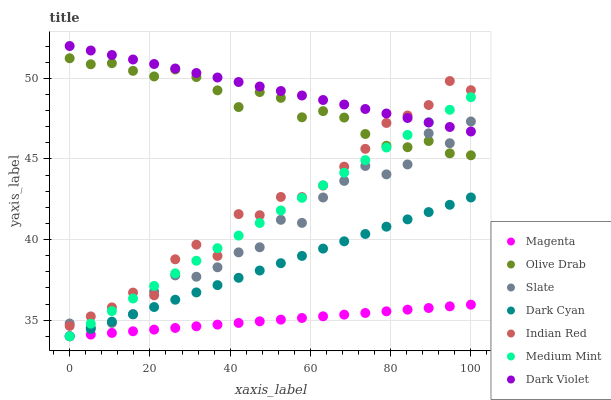Does Magenta have the minimum area under the curve?
Answer yes or no. Yes. Does Dark Violet have the maximum area under the curve?
Answer yes or no. Yes. Does Slate have the minimum area under the curve?
Answer yes or no. No. Does Slate have the maximum area under the curve?
Answer yes or no. No. Is Magenta the smoothest?
Answer yes or no. Yes. Is Indian Red the roughest?
Answer yes or no. Yes. Is Slate the smoothest?
Answer yes or no. No. Is Slate the roughest?
Answer yes or no. No. Does Medium Mint have the lowest value?
Answer yes or no. Yes. Does Slate have the lowest value?
Answer yes or no. No. Does Dark Violet have the highest value?
Answer yes or no. Yes. Does Slate have the highest value?
Answer yes or no. No. Is Magenta less than Dark Violet?
Answer yes or no. Yes. Is Dark Violet greater than Dark Cyan?
Answer yes or no. Yes. Does Indian Red intersect Slate?
Answer yes or no. Yes. Is Indian Red less than Slate?
Answer yes or no. No. Is Indian Red greater than Slate?
Answer yes or no. No. Does Magenta intersect Dark Violet?
Answer yes or no. No. 